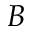<formula> <loc_0><loc_0><loc_500><loc_500>B</formula> 